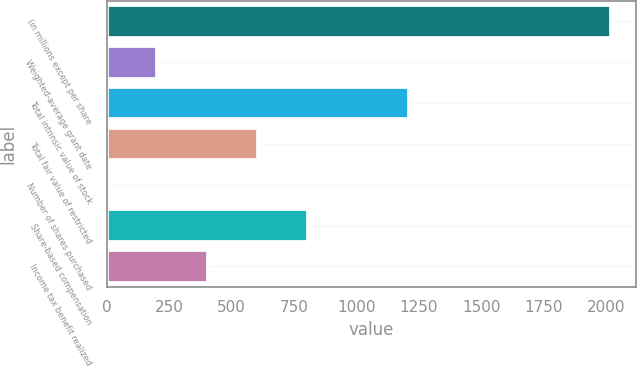<chart> <loc_0><loc_0><loc_500><loc_500><bar_chart><fcel>(in millions except per share<fcel>Weighted-average grant date<fcel>Total intrinsic value of stock<fcel>Total fair value of restricted<fcel>Number of shares purchased<fcel>Share-based compensation<fcel>Income tax benefit realized<nl><fcel>2016<fcel>203.4<fcel>1210.4<fcel>606.2<fcel>2<fcel>807.6<fcel>404.8<nl></chart> 